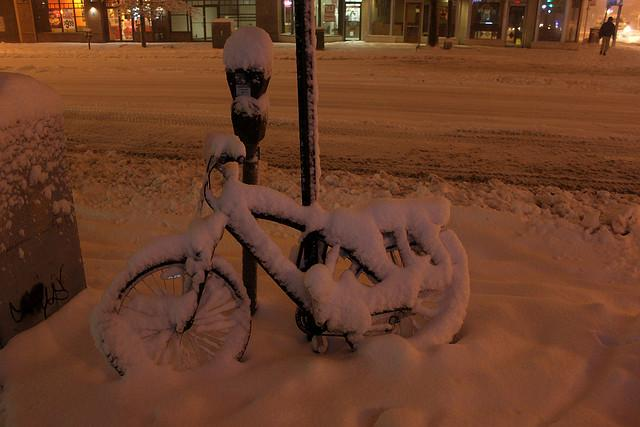How much did the owner of this bike put into the parking meter here? nothing 